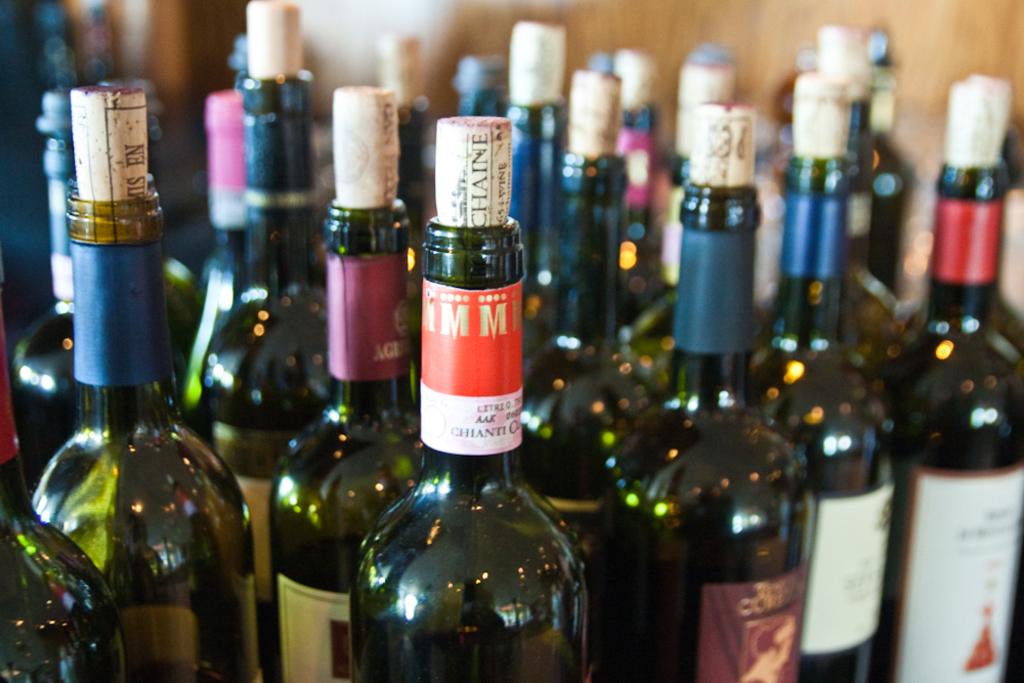What are the two prominent letters on the  label?
Keep it short and to the point. Mm. The name of what type of wine beginning with the letter c, can be red at the bottom of the red and white label on the neck of the bottle in the center?
Your answer should be very brief. Chianti. 